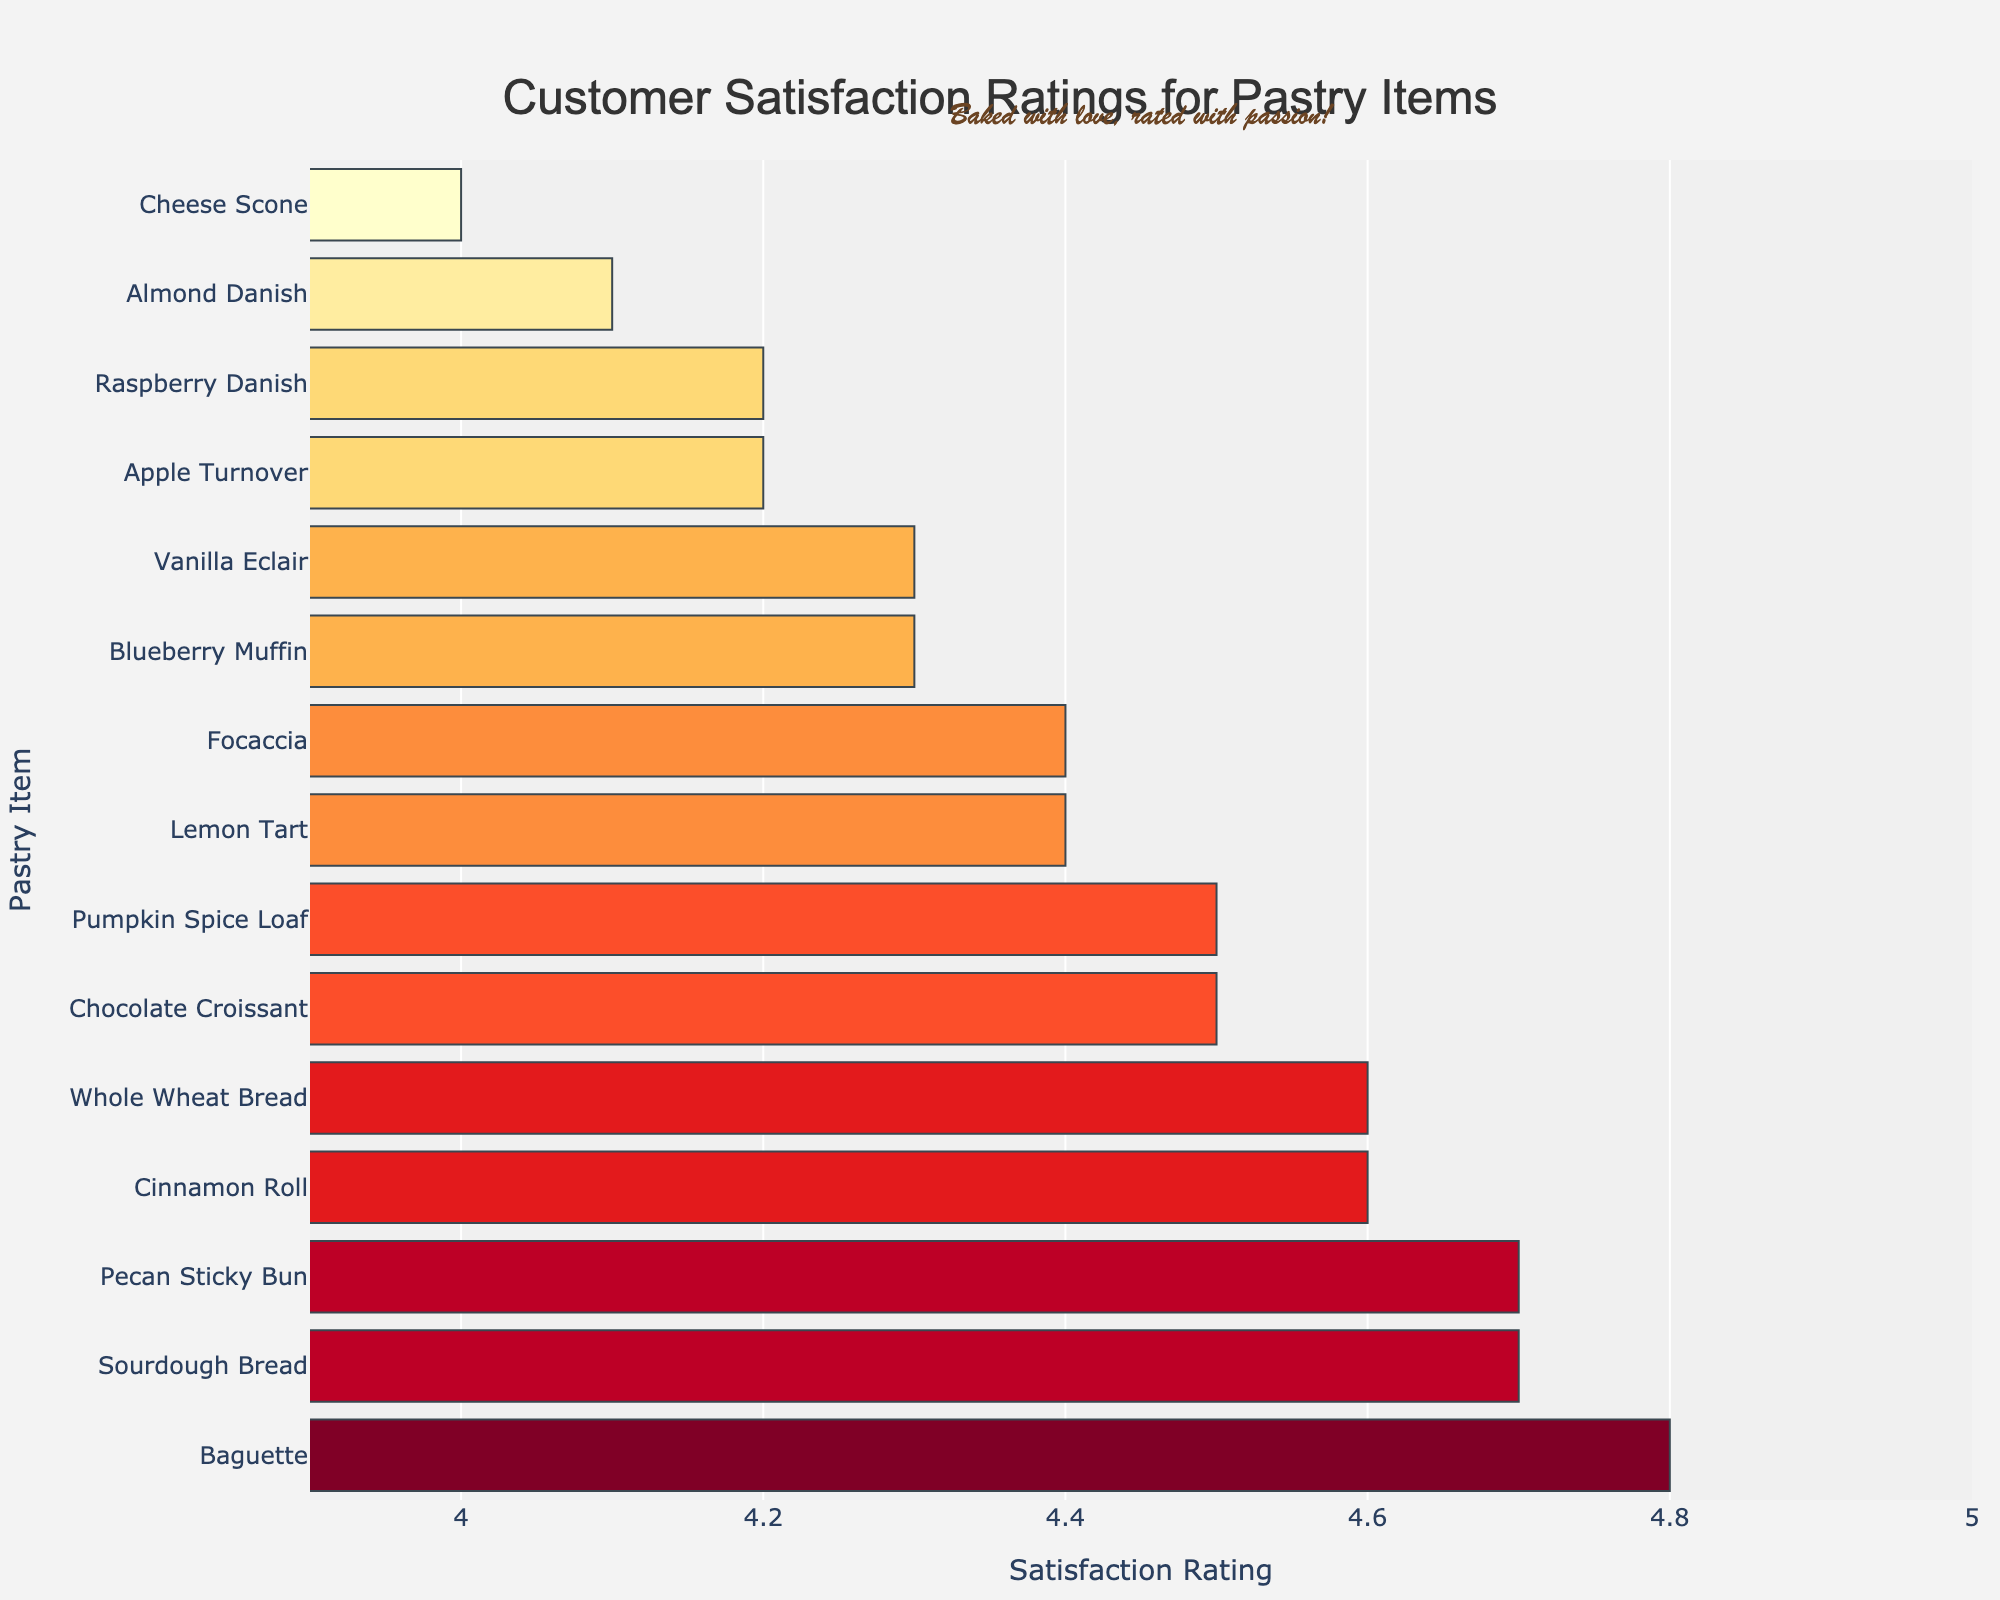Which pastry item has the highest customer satisfaction rating? The bar chart shows that the Baguette has the highest satisfaction rating.
Answer: Baguette Which pastry items have a satisfaction rating of 4.7? The bar chart shows that Sourdough Bread and Pecan Sticky Bun both have a satisfaction rating of 4.7.
Answer: Sourdough Bread, Pecan Sticky Bun What is the difference in satisfaction ratings between the highest-rated and lowest-rated pastry items? The highest rating is 4.8 (Baguette) and the lowest rating is 4.0 (Cheese Scone). The difference is 4.8 - 4.0.
Answer: 0.8 Which pastry item has a higher satisfaction rating: Lemon Tart or Focaccia? The bar chart shows that Lemon Tart has a satisfaction rating of 4.4, while Focaccia also has a rating of 4.4. They have the same satisfaction rating.
Answer: Equal What is the median satisfaction rating of the pastries? To find the median, list all the ratings: 4.8, 4.7, 4.7, 4.6, 4.6, 4.5, 4.5, 4.4, 4.4, 4.3, 4.3, 4.2, 4.2, 4.1, 4.0. The middle value, or median, is 4.4.
Answer: 4.4 How does the satisfaction rating of Whole Wheat Bread compare to that of Vanilla Eclair? Whole Wheat Bread has a satisfaction rating of 4.6, while Vanilla Eclair has a rating of 4.3. Thus, Whole Wheat Bread has a higher satisfaction rating.
Answer: Whole Wheat Bread is higher Which two pastry items have the same satisfaction rating and appear next to each other in the chart? The chart shows that Raspberry Danish and Apple Turnover both have a rating of 4.2 and appear next to each other.
Answer: Raspberry Danish, Apple Turnover What's the average satisfaction rating across all the pastry items? Sum all the ratings (4.7 + 4.5 + 4.3 + 4.6 + 4.2 + 4.8 + 4.4 + 4.1 + 4.0 + 4.5 + 4.2 + 4.6 + 4.3 + 4.7 + 4.4) to get 65.3, then divide by the number of items (15). The average is 65.3 / 15.
Answer: 4.35 